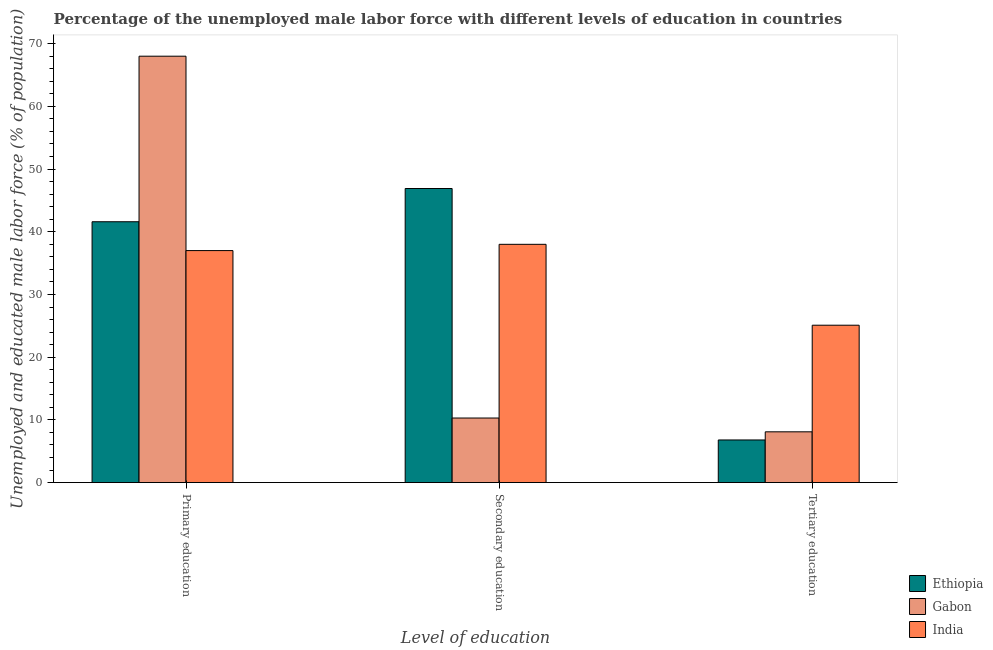Are the number of bars on each tick of the X-axis equal?
Give a very brief answer. Yes. What is the percentage of male labor force who received primary education in India?
Offer a very short reply. 37. Across all countries, what is the minimum percentage of male labor force who received primary education?
Offer a terse response. 37. In which country was the percentage of male labor force who received secondary education maximum?
Offer a terse response. Ethiopia. In which country was the percentage of male labor force who received secondary education minimum?
Your answer should be compact. Gabon. What is the total percentage of male labor force who received primary education in the graph?
Your answer should be compact. 146.6. What is the difference between the percentage of male labor force who received secondary education in Gabon and that in Ethiopia?
Make the answer very short. -36.6. What is the difference between the percentage of male labor force who received secondary education in Gabon and the percentage of male labor force who received primary education in India?
Offer a very short reply. -26.7. What is the average percentage of male labor force who received primary education per country?
Give a very brief answer. 48.87. What is the difference between the percentage of male labor force who received secondary education and percentage of male labor force who received primary education in Ethiopia?
Ensure brevity in your answer.  5.3. In how many countries, is the percentage of male labor force who received secondary education greater than 18 %?
Offer a very short reply. 2. What is the ratio of the percentage of male labor force who received secondary education in India to that in Ethiopia?
Provide a succinct answer. 0.81. Is the percentage of male labor force who received tertiary education in Gabon less than that in Ethiopia?
Keep it short and to the point. No. What is the difference between the highest and the second highest percentage of male labor force who received primary education?
Keep it short and to the point. 26.4. What does the 3rd bar from the left in Secondary education represents?
Offer a terse response. India. What does the 2nd bar from the right in Tertiary education represents?
Keep it short and to the point. Gabon. Is it the case that in every country, the sum of the percentage of male labor force who received primary education and percentage of male labor force who received secondary education is greater than the percentage of male labor force who received tertiary education?
Ensure brevity in your answer.  Yes. How many bars are there?
Make the answer very short. 9. How many countries are there in the graph?
Keep it short and to the point. 3. What is the difference between two consecutive major ticks on the Y-axis?
Your answer should be very brief. 10. Are the values on the major ticks of Y-axis written in scientific E-notation?
Your answer should be very brief. No. Does the graph contain any zero values?
Your response must be concise. No. Does the graph contain grids?
Your answer should be compact. No. Where does the legend appear in the graph?
Provide a succinct answer. Bottom right. How many legend labels are there?
Make the answer very short. 3. How are the legend labels stacked?
Keep it short and to the point. Vertical. What is the title of the graph?
Offer a terse response. Percentage of the unemployed male labor force with different levels of education in countries. Does "Paraguay" appear as one of the legend labels in the graph?
Offer a very short reply. No. What is the label or title of the X-axis?
Make the answer very short. Level of education. What is the label or title of the Y-axis?
Your answer should be compact. Unemployed and educated male labor force (% of population). What is the Unemployed and educated male labor force (% of population) in Ethiopia in Primary education?
Ensure brevity in your answer.  41.6. What is the Unemployed and educated male labor force (% of population) of India in Primary education?
Offer a very short reply. 37. What is the Unemployed and educated male labor force (% of population) in Ethiopia in Secondary education?
Ensure brevity in your answer.  46.9. What is the Unemployed and educated male labor force (% of population) of Gabon in Secondary education?
Give a very brief answer. 10.3. What is the Unemployed and educated male labor force (% of population) in India in Secondary education?
Keep it short and to the point. 38. What is the Unemployed and educated male labor force (% of population) of Ethiopia in Tertiary education?
Make the answer very short. 6.8. What is the Unemployed and educated male labor force (% of population) of Gabon in Tertiary education?
Ensure brevity in your answer.  8.1. What is the Unemployed and educated male labor force (% of population) of India in Tertiary education?
Your answer should be compact. 25.1. Across all Level of education, what is the maximum Unemployed and educated male labor force (% of population) in Ethiopia?
Your answer should be very brief. 46.9. Across all Level of education, what is the maximum Unemployed and educated male labor force (% of population) in Gabon?
Give a very brief answer. 68. Across all Level of education, what is the maximum Unemployed and educated male labor force (% of population) in India?
Your answer should be compact. 38. Across all Level of education, what is the minimum Unemployed and educated male labor force (% of population) of Ethiopia?
Give a very brief answer. 6.8. Across all Level of education, what is the minimum Unemployed and educated male labor force (% of population) of Gabon?
Provide a short and direct response. 8.1. Across all Level of education, what is the minimum Unemployed and educated male labor force (% of population) in India?
Your answer should be very brief. 25.1. What is the total Unemployed and educated male labor force (% of population) in Ethiopia in the graph?
Your response must be concise. 95.3. What is the total Unemployed and educated male labor force (% of population) in Gabon in the graph?
Provide a short and direct response. 86.4. What is the total Unemployed and educated male labor force (% of population) in India in the graph?
Offer a very short reply. 100.1. What is the difference between the Unemployed and educated male labor force (% of population) in Gabon in Primary education and that in Secondary education?
Offer a terse response. 57.7. What is the difference between the Unemployed and educated male labor force (% of population) of Ethiopia in Primary education and that in Tertiary education?
Your answer should be compact. 34.8. What is the difference between the Unemployed and educated male labor force (% of population) of Gabon in Primary education and that in Tertiary education?
Offer a very short reply. 59.9. What is the difference between the Unemployed and educated male labor force (% of population) of India in Primary education and that in Tertiary education?
Offer a very short reply. 11.9. What is the difference between the Unemployed and educated male labor force (% of population) in Ethiopia in Secondary education and that in Tertiary education?
Your answer should be very brief. 40.1. What is the difference between the Unemployed and educated male labor force (% of population) in Ethiopia in Primary education and the Unemployed and educated male labor force (% of population) in Gabon in Secondary education?
Keep it short and to the point. 31.3. What is the difference between the Unemployed and educated male labor force (% of population) in Ethiopia in Primary education and the Unemployed and educated male labor force (% of population) in India in Secondary education?
Offer a very short reply. 3.6. What is the difference between the Unemployed and educated male labor force (% of population) of Ethiopia in Primary education and the Unemployed and educated male labor force (% of population) of Gabon in Tertiary education?
Provide a short and direct response. 33.5. What is the difference between the Unemployed and educated male labor force (% of population) of Gabon in Primary education and the Unemployed and educated male labor force (% of population) of India in Tertiary education?
Make the answer very short. 42.9. What is the difference between the Unemployed and educated male labor force (% of population) of Ethiopia in Secondary education and the Unemployed and educated male labor force (% of population) of Gabon in Tertiary education?
Your response must be concise. 38.8. What is the difference between the Unemployed and educated male labor force (% of population) in Ethiopia in Secondary education and the Unemployed and educated male labor force (% of population) in India in Tertiary education?
Ensure brevity in your answer.  21.8. What is the difference between the Unemployed and educated male labor force (% of population) of Gabon in Secondary education and the Unemployed and educated male labor force (% of population) of India in Tertiary education?
Make the answer very short. -14.8. What is the average Unemployed and educated male labor force (% of population) in Ethiopia per Level of education?
Your response must be concise. 31.77. What is the average Unemployed and educated male labor force (% of population) in Gabon per Level of education?
Offer a very short reply. 28.8. What is the average Unemployed and educated male labor force (% of population) in India per Level of education?
Your answer should be compact. 33.37. What is the difference between the Unemployed and educated male labor force (% of population) of Ethiopia and Unemployed and educated male labor force (% of population) of Gabon in Primary education?
Make the answer very short. -26.4. What is the difference between the Unemployed and educated male labor force (% of population) in Gabon and Unemployed and educated male labor force (% of population) in India in Primary education?
Ensure brevity in your answer.  31. What is the difference between the Unemployed and educated male labor force (% of population) of Ethiopia and Unemployed and educated male labor force (% of population) of Gabon in Secondary education?
Your answer should be compact. 36.6. What is the difference between the Unemployed and educated male labor force (% of population) of Gabon and Unemployed and educated male labor force (% of population) of India in Secondary education?
Give a very brief answer. -27.7. What is the difference between the Unemployed and educated male labor force (% of population) of Ethiopia and Unemployed and educated male labor force (% of population) of Gabon in Tertiary education?
Ensure brevity in your answer.  -1.3. What is the difference between the Unemployed and educated male labor force (% of population) in Ethiopia and Unemployed and educated male labor force (% of population) in India in Tertiary education?
Give a very brief answer. -18.3. What is the difference between the Unemployed and educated male labor force (% of population) in Gabon and Unemployed and educated male labor force (% of population) in India in Tertiary education?
Provide a succinct answer. -17. What is the ratio of the Unemployed and educated male labor force (% of population) of Ethiopia in Primary education to that in Secondary education?
Make the answer very short. 0.89. What is the ratio of the Unemployed and educated male labor force (% of population) in Gabon in Primary education to that in Secondary education?
Keep it short and to the point. 6.6. What is the ratio of the Unemployed and educated male labor force (% of population) in India in Primary education to that in Secondary education?
Ensure brevity in your answer.  0.97. What is the ratio of the Unemployed and educated male labor force (% of population) in Ethiopia in Primary education to that in Tertiary education?
Provide a short and direct response. 6.12. What is the ratio of the Unemployed and educated male labor force (% of population) of Gabon in Primary education to that in Tertiary education?
Provide a short and direct response. 8.4. What is the ratio of the Unemployed and educated male labor force (% of population) in India in Primary education to that in Tertiary education?
Provide a short and direct response. 1.47. What is the ratio of the Unemployed and educated male labor force (% of population) in Ethiopia in Secondary education to that in Tertiary education?
Offer a very short reply. 6.9. What is the ratio of the Unemployed and educated male labor force (% of population) in Gabon in Secondary education to that in Tertiary education?
Provide a succinct answer. 1.27. What is the ratio of the Unemployed and educated male labor force (% of population) of India in Secondary education to that in Tertiary education?
Make the answer very short. 1.51. What is the difference between the highest and the second highest Unemployed and educated male labor force (% of population) in Gabon?
Provide a short and direct response. 57.7. What is the difference between the highest and the second highest Unemployed and educated male labor force (% of population) in India?
Your response must be concise. 1. What is the difference between the highest and the lowest Unemployed and educated male labor force (% of population) of Ethiopia?
Provide a succinct answer. 40.1. What is the difference between the highest and the lowest Unemployed and educated male labor force (% of population) in Gabon?
Your response must be concise. 59.9. What is the difference between the highest and the lowest Unemployed and educated male labor force (% of population) of India?
Your answer should be compact. 12.9. 